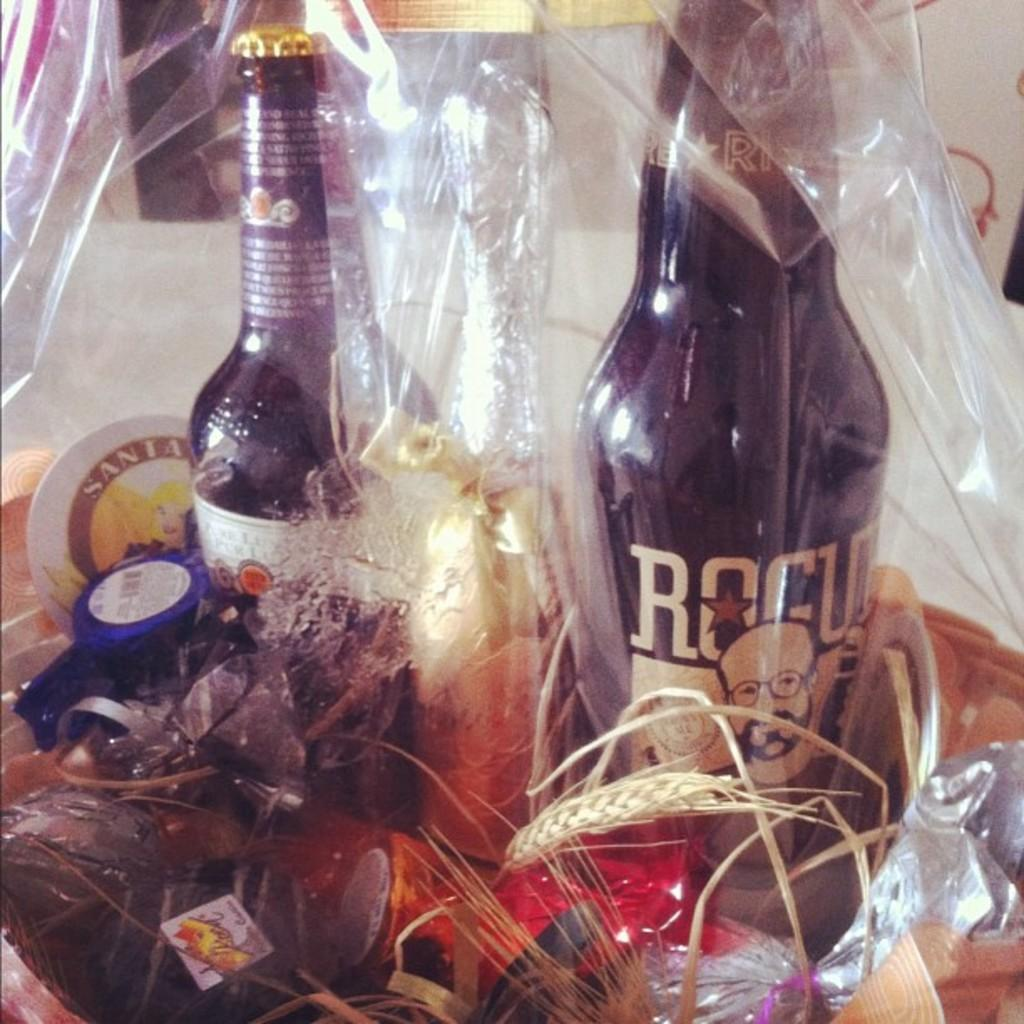What type of items can be seen in the image? There are bottles, chocolates, and other wrappers in the image. How are these items contained in the image? These objects are inside a polythene. What type of coal can be seen in the image? There is no coal present in the image. What time of day is depicted in the image? The time of day is not mentioned or depicted in the image. 